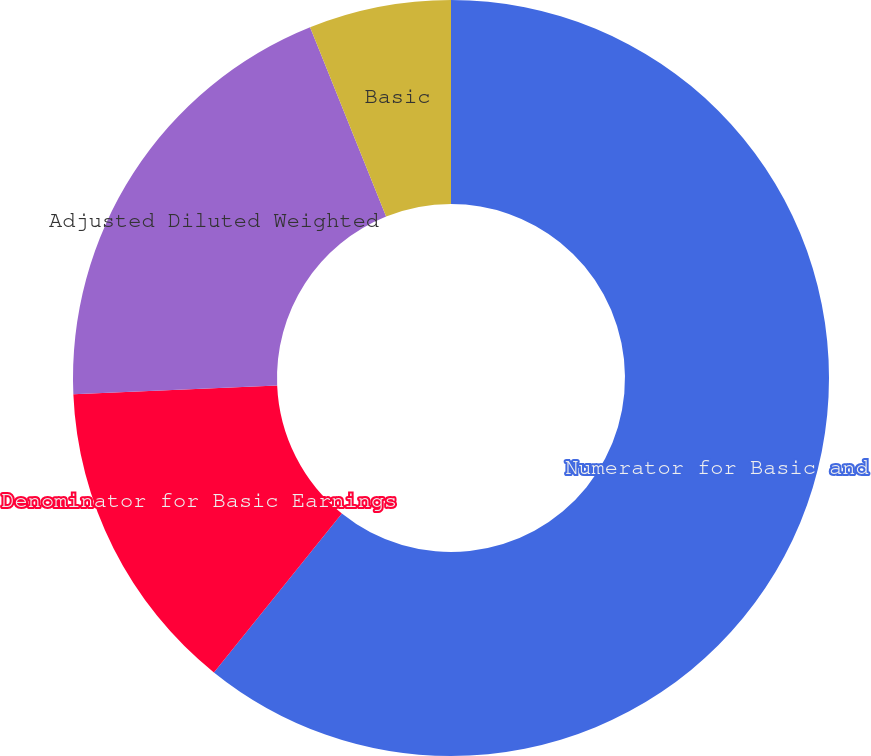Convert chart to OTSL. <chart><loc_0><loc_0><loc_500><loc_500><pie_chart><fcel>Numerator for Basic and<fcel>Denominator for Basic Earnings<fcel>Adjusted Diluted Weighted<fcel>Basic<fcel>Diluted<nl><fcel>60.79%<fcel>13.53%<fcel>19.6%<fcel>6.08%<fcel>0.0%<nl></chart> 